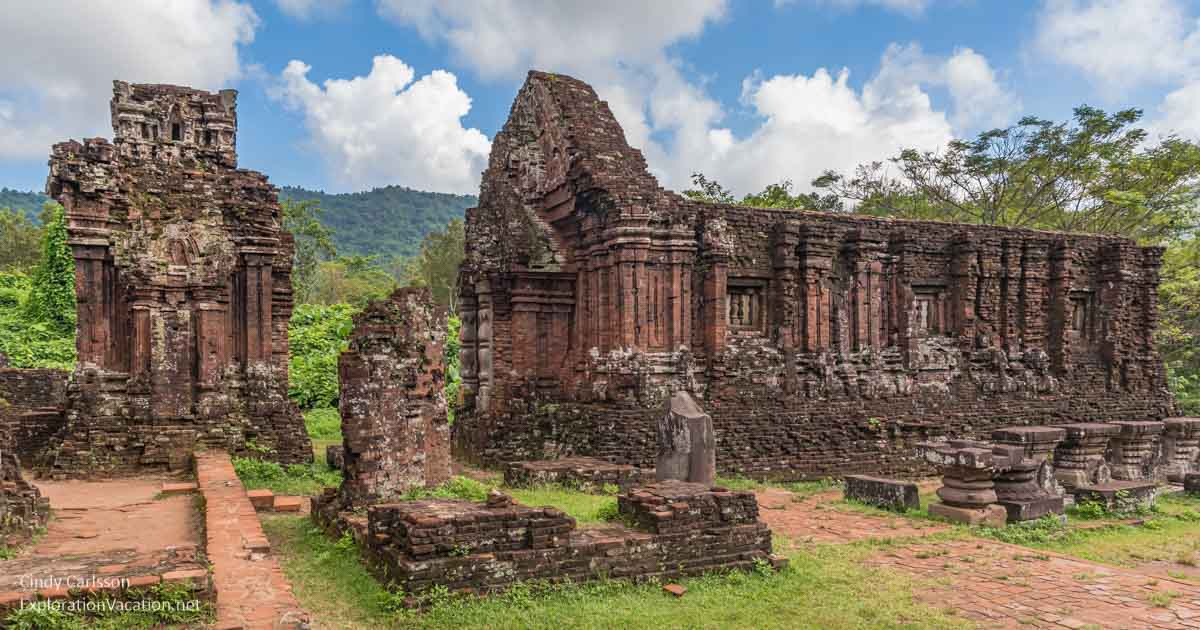Imagine a hidden treasure within the ruins. What could it be? Envision a hidden chamber deep within the ruins of the My Son temple complex, sealed for centuries and only recently unearthed. Inside this chamber, an exhilarating discovery awaits – an ancient, jewel-encrusted statue of Shiva, meticulously crafted from pure gold and adorned with precious stones. Alongside it, a collection of palm leaf manuscripts, beautifully preserved, contains detailed scriptures, chanting rituals, and records of the Champa kingdom’s history and religious practices. This extraordinary find not only holds immense material value but also offers an unparalleled glimpse into the spiritual life and artistic prowess of an ancient civilization, rekindling the glory and mystique of My Son. 